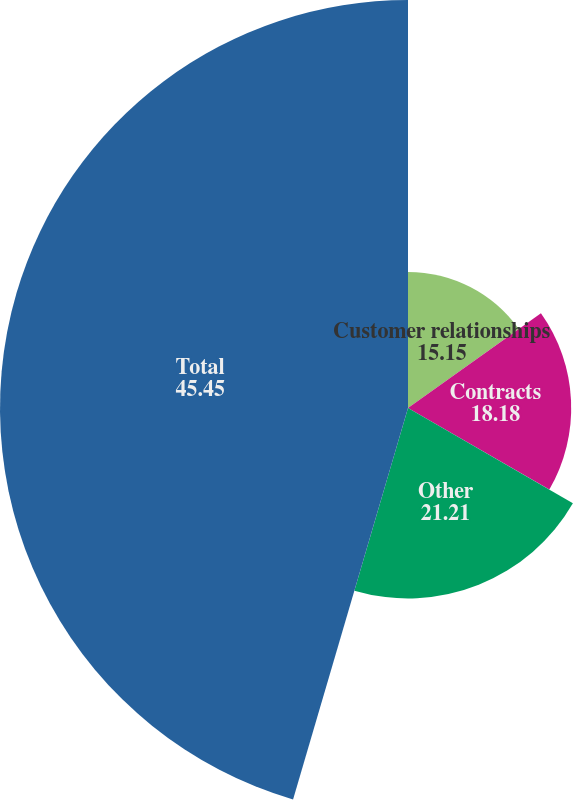<chart> <loc_0><loc_0><loc_500><loc_500><pie_chart><fcel>Customer relationships<fcel>Contracts<fcel>Other<fcel>Total<nl><fcel>15.15%<fcel>18.18%<fcel>21.21%<fcel>45.45%<nl></chart> 